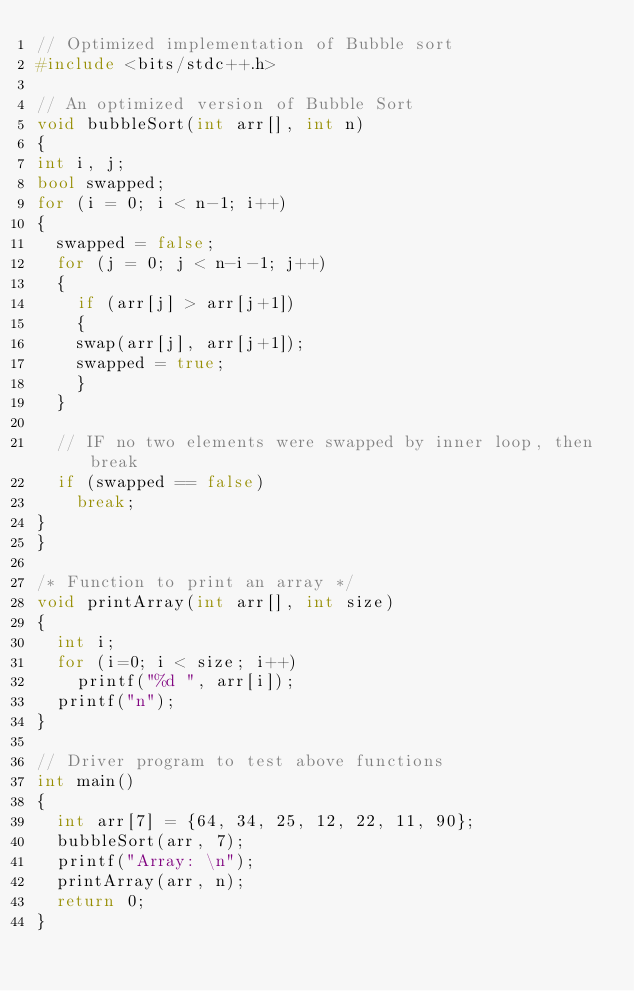Convert code to text. <code><loc_0><loc_0><loc_500><loc_500><_C++_>// Optimized implementation of Bubble sort 
#include <bits/stdc++.h> 

// An optimized version of Bubble Sort 
void bubbleSort(int arr[], int n) 
{ 
int i, j; 
bool swapped; 
for (i = 0; i < n-1; i++) 
{ 
  swapped = false; 
  for (j = 0; j < n-i-1; j++) 
  { 
    if (arr[j] > arr[j+1]) 
    { 
    swap(arr[j], arr[j+1]); 
    swapped = true; 
    } 
  } 

  // IF no two elements were swapped by inner loop, then break 
  if (swapped == false) 
    break; 
} 
} 

/* Function to print an array */
void printArray(int arr[], int size) 
{ 
  int i; 
  for (i=0; i < size; i++) 
    printf("%d ", arr[i]); 
  printf("n"); 
} 

// Driver program to test above functions 
int main() 
{ 
  int arr[7] = {64, 34, 25, 12, 22, 11, 90}; 
  bubbleSort(arr, 7); 
  printf("Array: \n"); 
  printArray(arr, n); 
  return 0; 
} 
</code> 